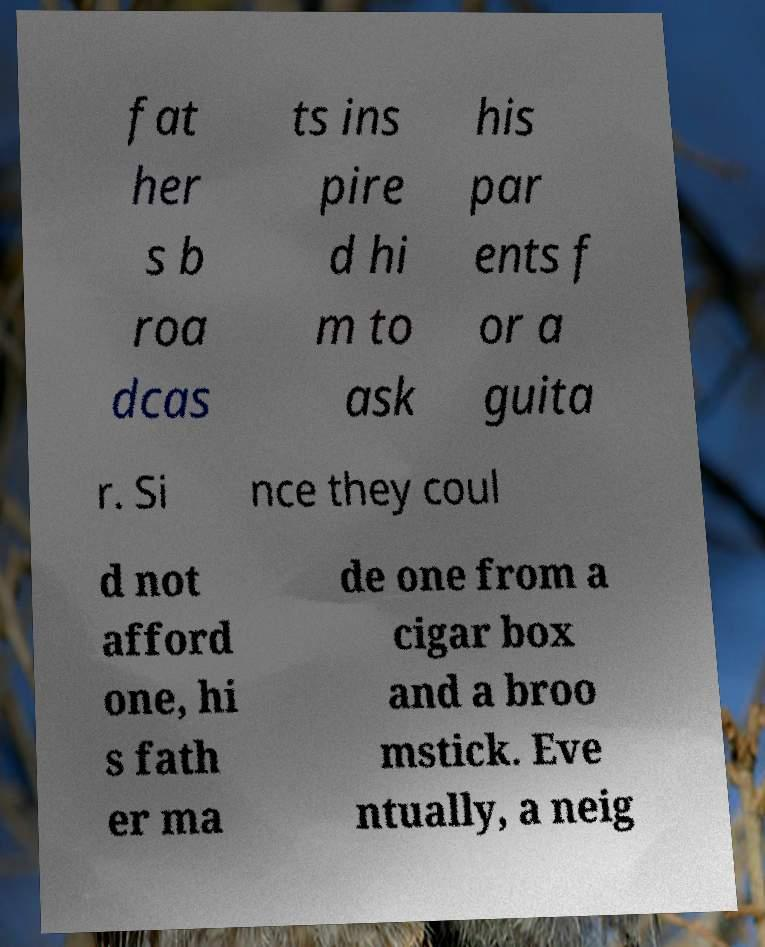Can you accurately transcribe the text from the provided image for me? fat her s b roa dcas ts ins pire d hi m to ask his par ents f or a guita r. Si nce they coul d not afford one, hi s fath er ma de one from a cigar box and a broo mstick. Eve ntually, a neig 